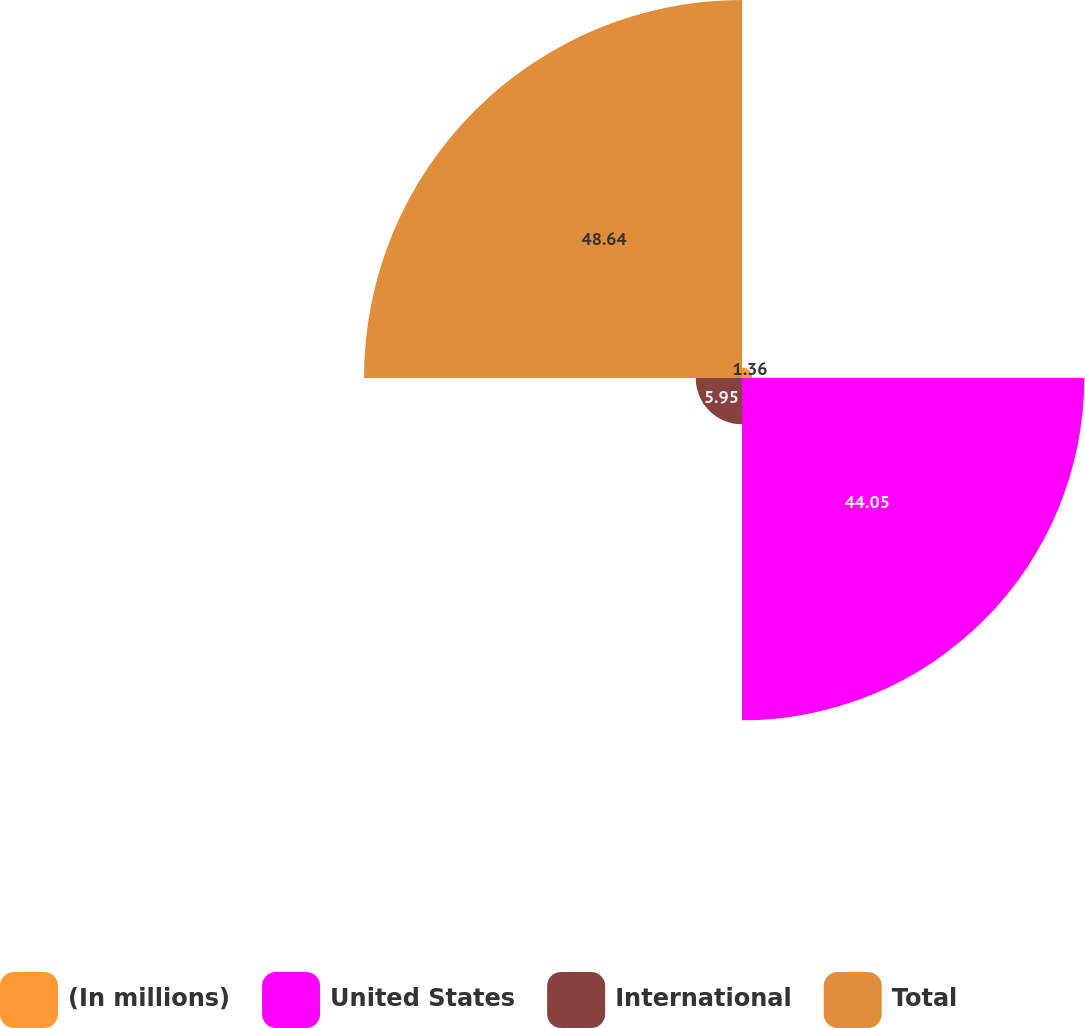Convert chart. <chart><loc_0><loc_0><loc_500><loc_500><pie_chart><fcel>(In millions)<fcel>United States<fcel>International<fcel>Total<nl><fcel>1.36%<fcel>44.05%<fcel>5.95%<fcel>48.64%<nl></chart> 